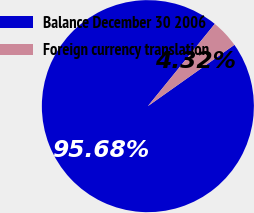Convert chart. <chart><loc_0><loc_0><loc_500><loc_500><pie_chart><fcel>Balance December 30 2006<fcel>Foreign currency translation<nl><fcel>95.68%<fcel>4.32%<nl></chart> 